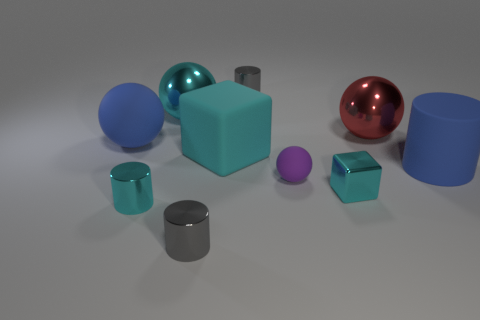Are there more metallic objects or more plastic-looking ones? There appear to be an equal number of objects that have a metallic sheen and ones with a matte, plastic-like appearance, with each category having three items. 